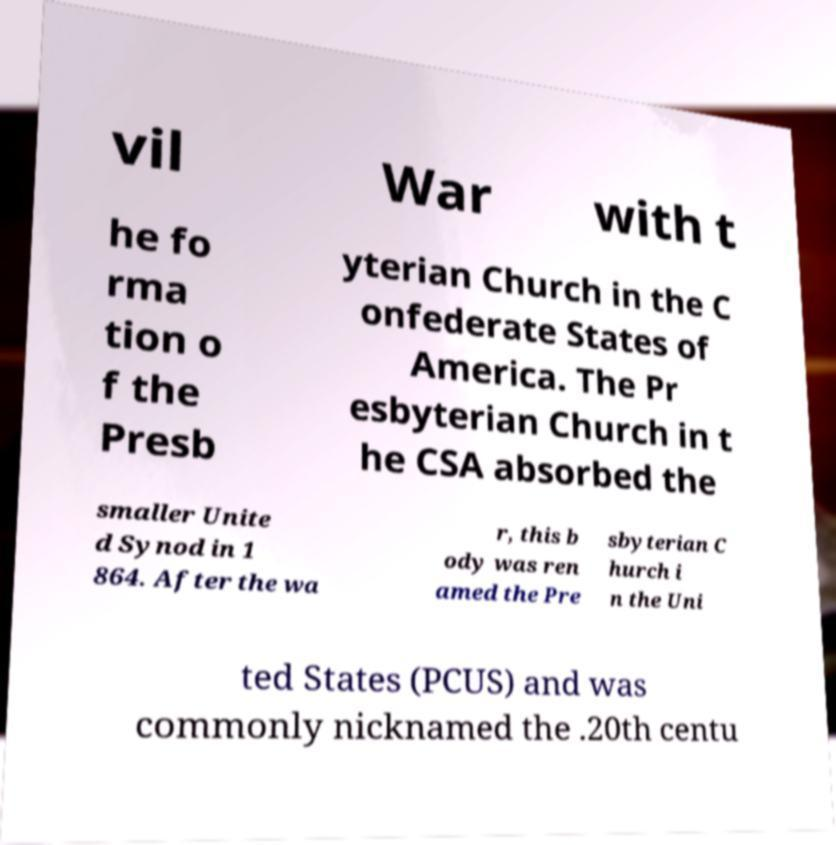Could you extract and type out the text from this image? vil War with t he fo rma tion o f the Presb yterian Church in the C onfederate States of America. The Pr esbyterian Church in t he CSA absorbed the smaller Unite d Synod in 1 864. After the wa r, this b ody was ren amed the Pre sbyterian C hurch i n the Uni ted States (PCUS) and was commonly nicknamed the .20th centu 